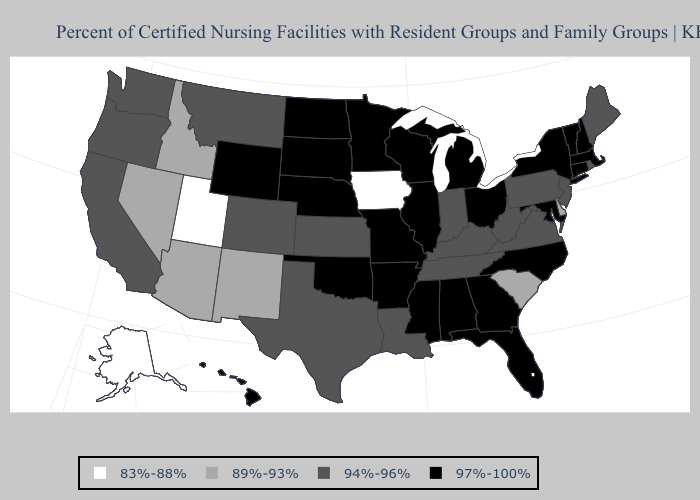What is the value of Massachusetts?
Answer briefly. 97%-100%. Does North Carolina have the lowest value in the South?
Keep it brief. No. What is the highest value in the Northeast ?
Write a very short answer. 97%-100%. Among the states that border New Jersey , which have the highest value?
Quick response, please. New York. What is the value of Colorado?
Concise answer only. 94%-96%. How many symbols are there in the legend?
Write a very short answer. 4. Name the states that have a value in the range 97%-100%?
Short answer required. Alabama, Arkansas, Connecticut, Florida, Georgia, Hawaii, Illinois, Maryland, Massachusetts, Michigan, Minnesota, Mississippi, Missouri, Nebraska, New Hampshire, New York, North Carolina, North Dakota, Ohio, Oklahoma, South Dakota, Vermont, Wisconsin, Wyoming. What is the highest value in the South ?
Concise answer only. 97%-100%. What is the value of Alaska?
Answer briefly. 83%-88%. What is the value of Colorado?
Give a very brief answer. 94%-96%. Name the states that have a value in the range 83%-88%?
Short answer required. Alaska, Iowa, Utah. Does Kentucky have a higher value than Maine?
Be succinct. No. How many symbols are there in the legend?
Quick response, please. 4. What is the highest value in the MidWest ?
Keep it brief. 97%-100%. 